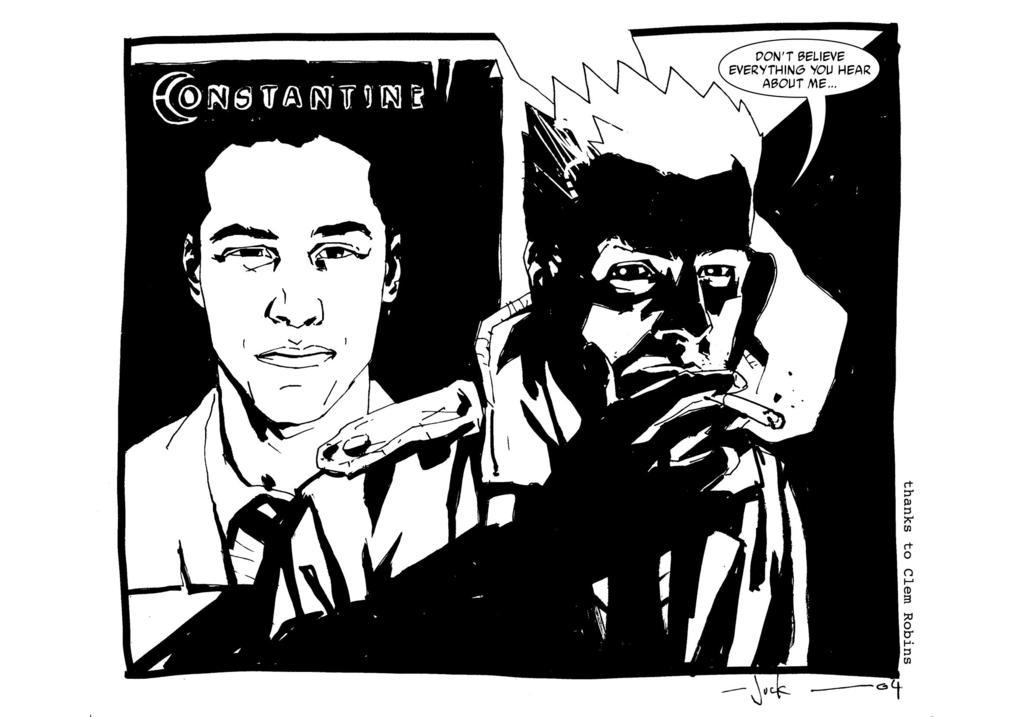What type of image is present in the picture? There is a comic in the image. How many people are depicted in the comic? There are two persons in the comic. Is there any text present in the comic? Yes, there is text written on the comic. What type of bell can be seen in the comic? There is no bell present in the comic; it features two persons and text. 